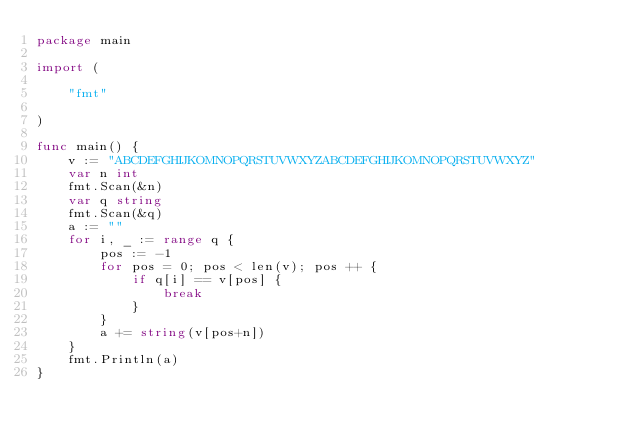Convert code to text. <code><loc_0><loc_0><loc_500><loc_500><_Go_>package main

import (

	"fmt"

)

func main() {
	v := "ABCDEFGHIJKOMNOPQRSTUVWXYZABCDEFGHIJKOMNOPQRSTUVWXYZ"
	var n int
	fmt.Scan(&n)
	var q string
	fmt.Scan(&q)
	a := ""
	for i, _ := range q {
		pos := -1
		for pos = 0; pos < len(v); pos ++ {
			if q[i] == v[pos] {
				break
			}
		}
		a += string(v[pos+n])
	}
	fmt.Println(a)
}


</code> 